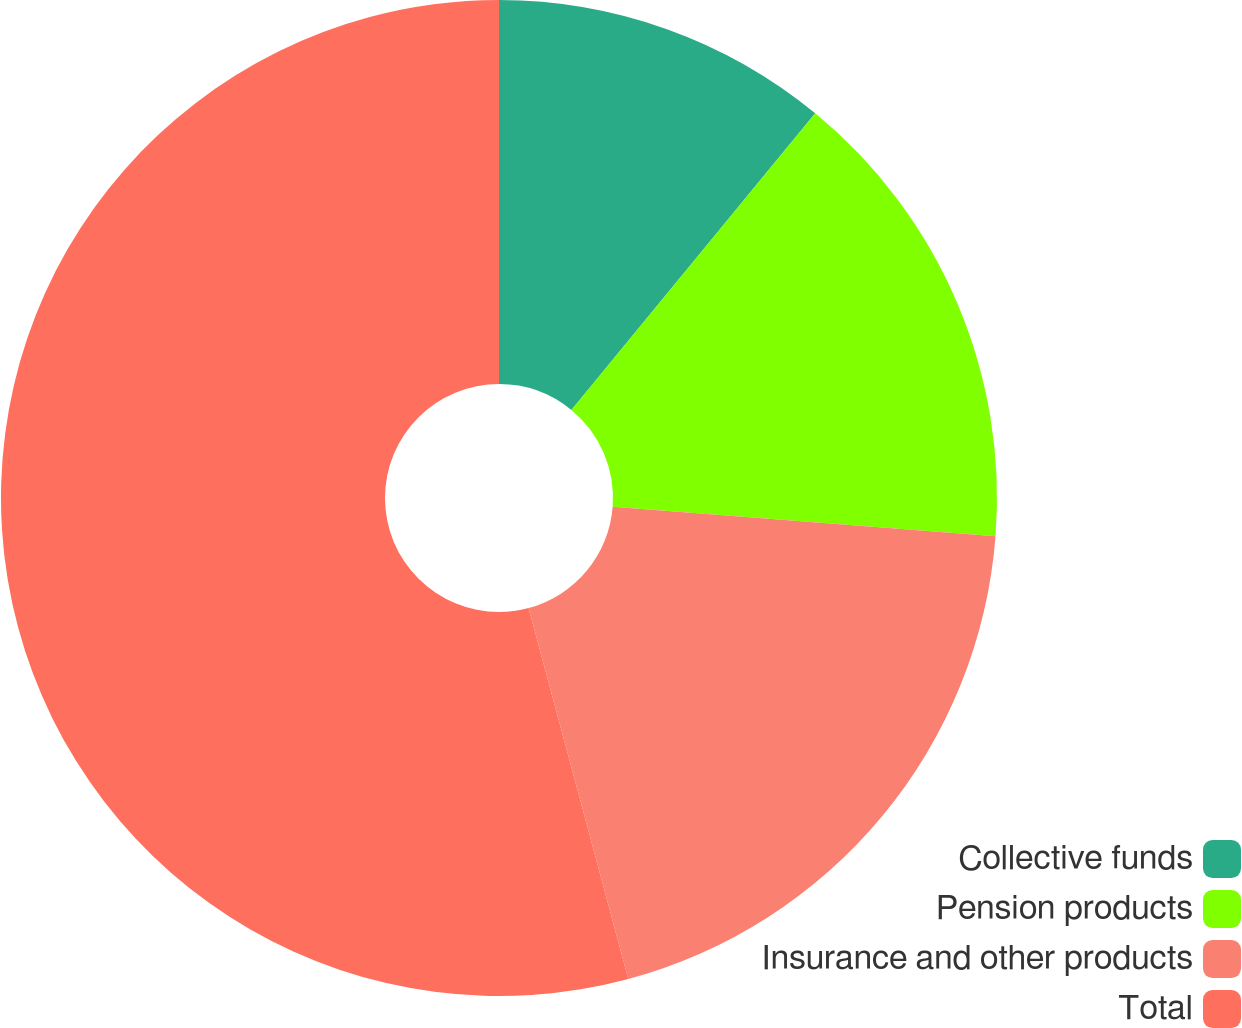<chart> <loc_0><loc_0><loc_500><loc_500><pie_chart><fcel>Collective funds<fcel>Pension products<fcel>Insurance and other products<fcel>Total<nl><fcel>10.95%<fcel>15.27%<fcel>19.6%<fcel>54.18%<nl></chart> 